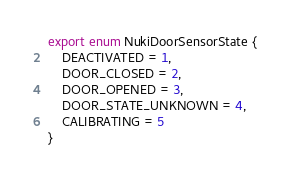<code> <loc_0><loc_0><loc_500><loc_500><_TypeScript_>export enum NukiDoorSensorState {
    DEACTIVATED = 1,
    DOOR_CLOSED = 2,
    DOOR_OPENED = 3,
    DOOR_STATE_UNKNOWN = 4,
    CALIBRATING = 5
}
</code> 